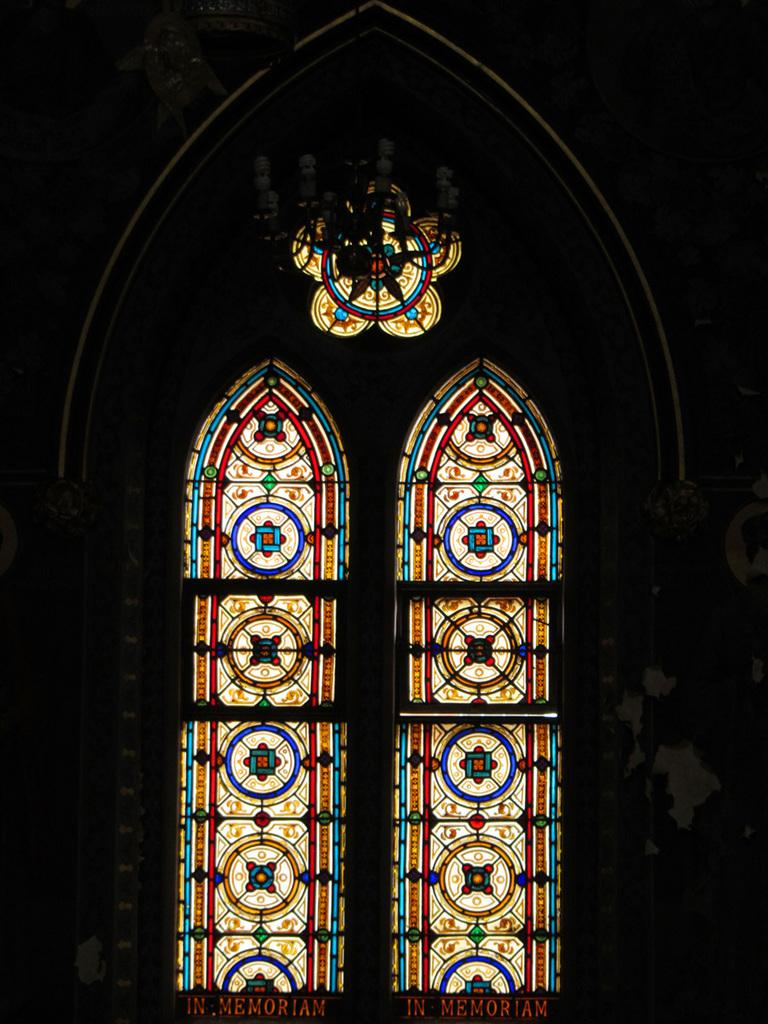What type of openings can be seen in the image? There are windows in the image. What can be found written or printed in the image? There are names visible in the image. What else is present in the image besides the windows and names? There are objects in the image. How would you describe the overall lighting in the image? The background of the image is dark. How many geese are visible in the image? There are no geese present in the image. What type of trousers are the geese wearing in the image? There are no geese or trousers present in the image. 